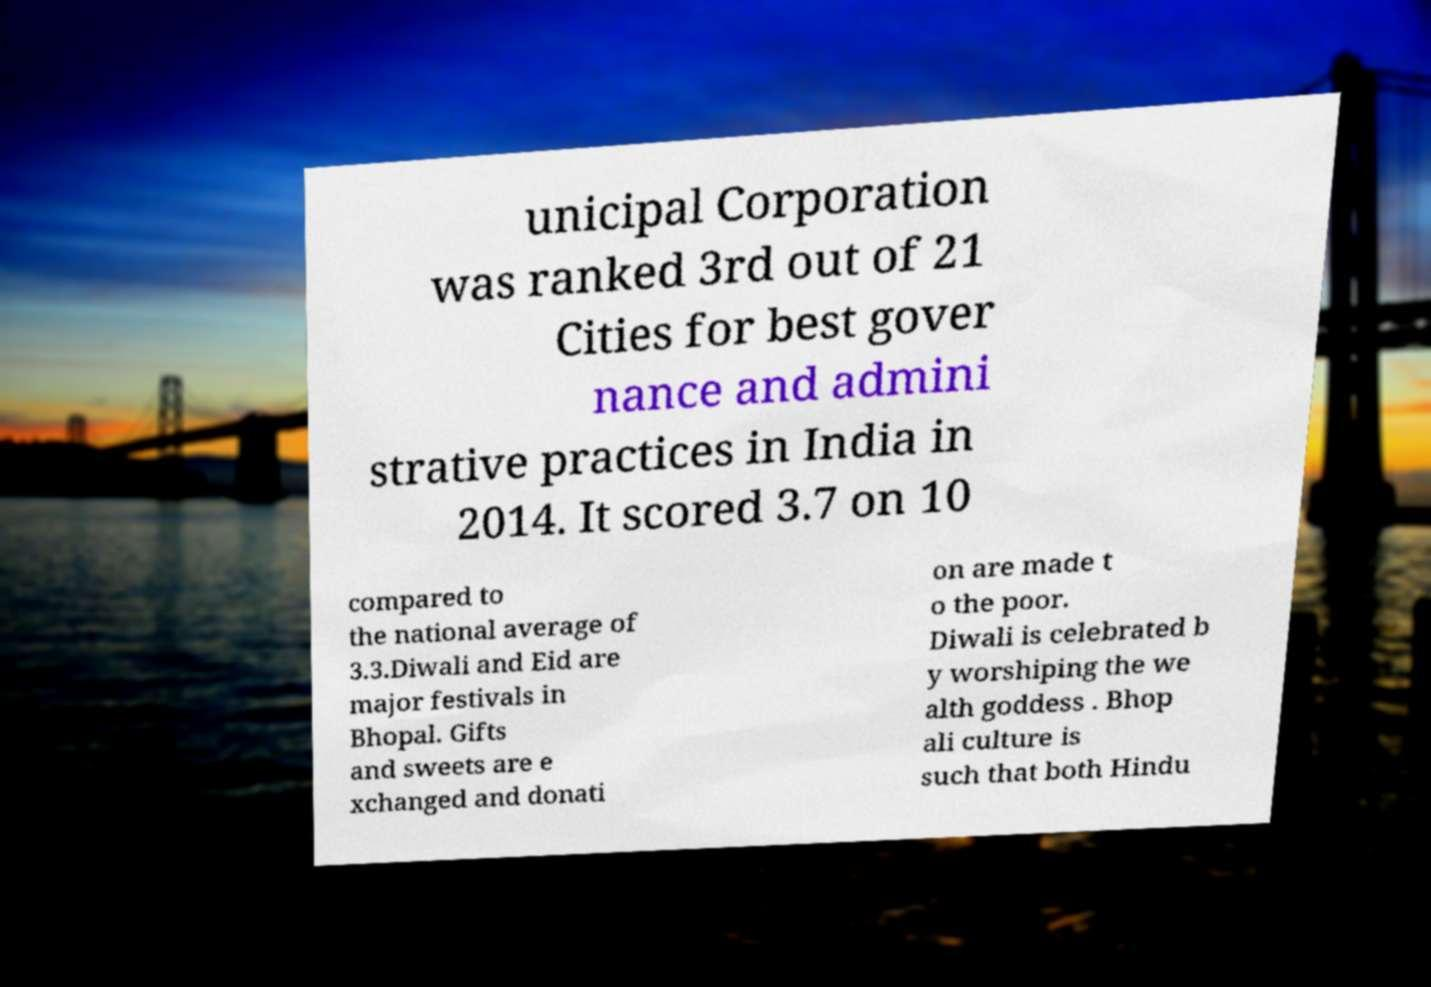Could you extract and type out the text from this image? unicipal Corporation was ranked 3rd out of 21 Cities for best gover nance and admini strative practices in India in 2014. It scored 3.7 on 10 compared to the national average of 3.3.Diwali and Eid are major festivals in Bhopal. Gifts and sweets are e xchanged and donati on are made t o the poor. Diwali is celebrated b y worshiping the we alth goddess . Bhop ali culture is such that both Hindu 